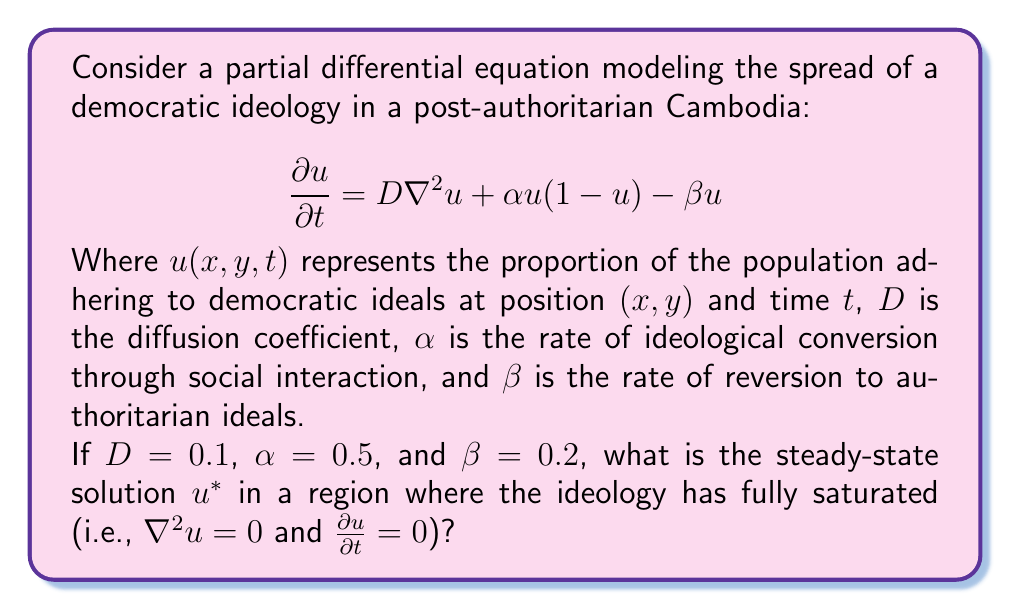Help me with this question. To find the steady-state solution, we follow these steps:

1) In the steady state, both time derivative and spatial derivatives are zero:
   $$\frac{\partial u}{\partial t} = 0$$ and $$\nabla^2u = 0$$

2) Substituting these into the original equation:
   $$0 = D(0) + \alpha u(1-u) - \beta u$$

3) Simplifying:
   $$0 = \alpha u(1-u) - \beta u$$

4) Factor out $u$:
   $$0 = u(\alpha(1-u) - \beta)$$

5) This equation has two solutions: $u = 0$ or $\alpha(1-u) - \beta = 0$

6) We're interested in the non-zero solution, so solve:
   $$\alpha(1-u) - \beta = 0$$
   $$\alpha - \alpha u - \beta = 0$$
   $$\alpha - \beta = \alpha u$$
   $$u = \frac{\alpha - \beta}{\alpha}$$

7) Substitute the given values $\alpha = 0.5$ and $\beta = 0.2$:
   $$u^* = \frac{0.5 - 0.2}{0.5} = \frac{0.3}{0.5} = 0.6$$

This steady-state solution represents the long-term proportion of the population adhering to democratic ideals in regions where the ideology has fully saturated.
Answer: $u^* = 0.6$ 